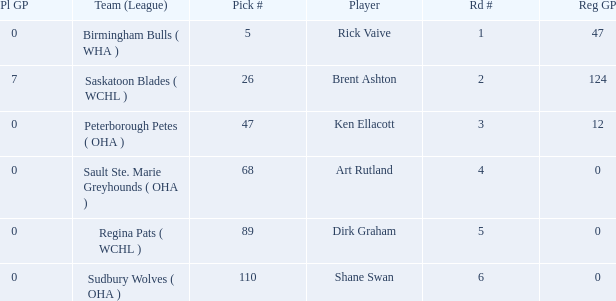How many reg GP for rick vaive in round 1? None. 